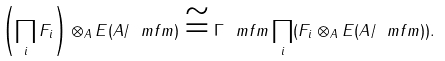<formula> <loc_0><loc_0><loc_500><loc_500>\left ( \prod _ { i } F _ { i } \right ) \otimes _ { A } E ( A / \ m f { m } ) \cong \Gamma _ { \ } m f { m } \prod _ { i } ( F _ { i } \otimes _ { A } E ( A / \ m f { m } ) ) .</formula> 